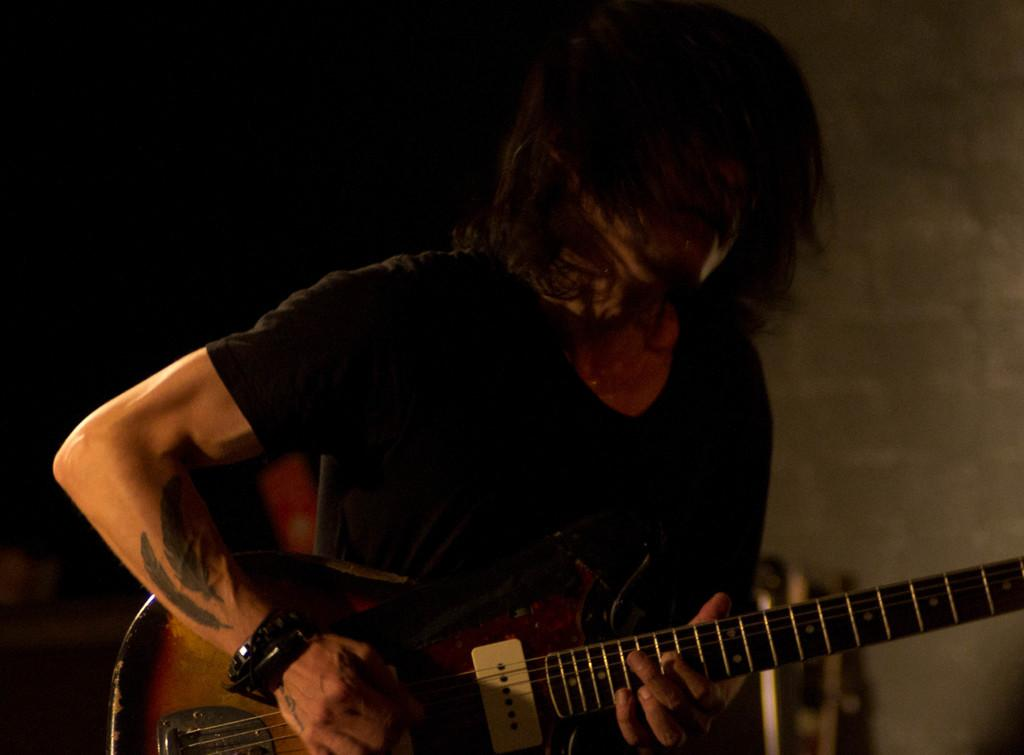Who is present in the image? There is a man in the image. What is the man wearing? The man is wearing a black dress. What is the man holding in his hand? The man is holding a guitar in his hand. What type of example can be seen in the picture frame? There is no picture frame present in the image, so it is not possible to determine what type of example might be seen. 